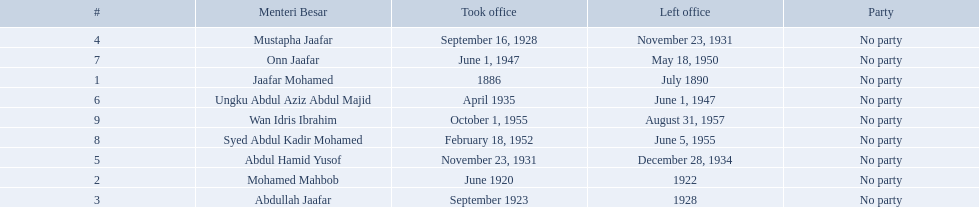Who are all of the menteri besars? Jaafar Mohamed, Mohamed Mahbob, Abdullah Jaafar, Mustapha Jaafar, Abdul Hamid Yusof, Ungku Abdul Aziz Abdul Majid, Onn Jaafar, Syed Abdul Kadir Mohamed, Wan Idris Ibrahim. When did each take office? 1886, June 1920, September 1923, September 16, 1928, November 23, 1931, April 1935, June 1, 1947, February 18, 1952, October 1, 1955. When did they leave? July 1890, 1922, 1928, November 23, 1931, December 28, 1934, June 1, 1947, May 18, 1950, June 5, 1955, August 31, 1957. And which spent the most time in office? Ungku Abdul Aziz Abdul Majid. 